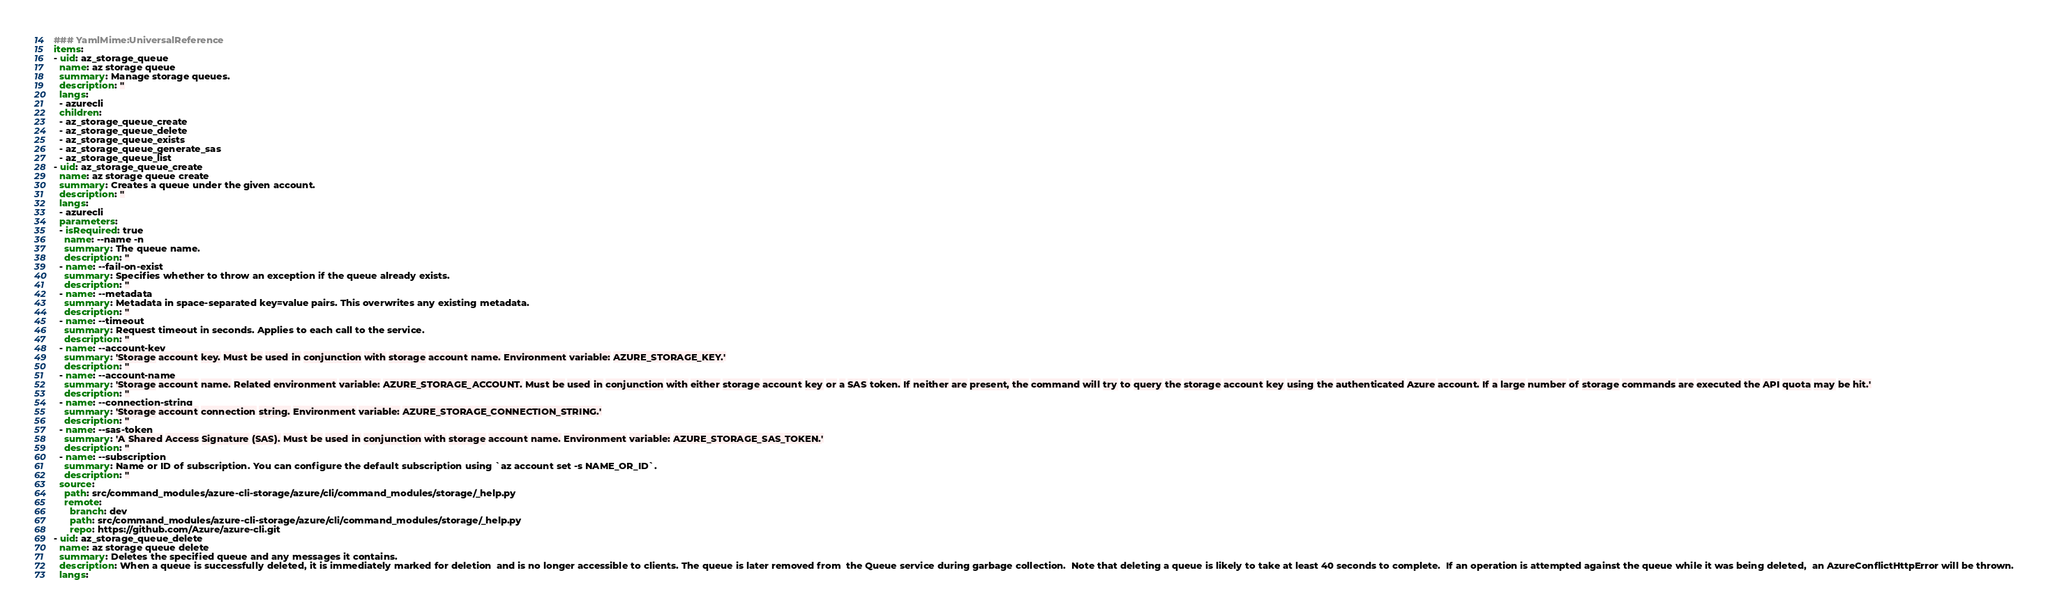<code> <loc_0><loc_0><loc_500><loc_500><_YAML_>### YamlMime:UniversalReference
items:
- uid: az_storage_queue
  name: az storage queue
  summary: Manage storage queues.
  description: ''
  langs:
  - azurecli
  children:
  - az_storage_queue_create
  - az_storage_queue_delete
  - az_storage_queue_exists
  - az_storage_queue_generate_sas
  - az_storage_queue_list
- uid: az_storage_queue_create
  name: az storage queue create
  summary: Creates a queue under the given account.
  description: ''
  langs:
  - azurecli
  parameters:
  - isRequired: true
    name: --name -n
    summary: The queue name.
    description: ''
  - name: --fail-on-exist
    summary: Specifies whether to throw an exception if the queue already exists.
    description: ''
  - name: --metadata
    summary: Metadata in space-separated key=value pairs. This overwrites any existing metadata.
    description: ''
  - name: --timeout
    summary: Request timeout in seconds. Applies to each call to the service.
    description: ''
  - name: --account-key
    summary: 'Storage account key. Must be used in conjunction with storage account name. Environment variable: AZURE_STORAGE_KEY.'
    description: ''
  - name: --account-name
    summary: 'Storage account name. Related environment variable: AZURE_STORAGE_ACCOUNT. Must be used in conjunction with either storage account key or a SAS token. If neither are present, the command will try to query the storage account key using the authenticated Azure account. If a large number of storage commands are executed the API quota may be hit.'
    description: ''
  - name: --connection-string
    summary: 'Storage account connection string. Environment variable: AZURE_STORAGE_CONNECTION_STRING.'
    description: ''
  - name: --sas-token
    summary: 'A Shared Access Signature (SAS). Must be used in conjunction with storage account name. Environment variable: AZURE_STORAGE_SAS_TOKEN.'
    description: ''
  - name: --subscription
    summary: Name or ID of subscription. You can configure the default subscription using `az account set -s NAME_OR_ID`.
    description: ''
  source:
    path: src/command_modules/azure-cli-storage/azure/cli/command_modules/storage/_help.py
    remote:
      branch: dev
      path: src/command_modules/azure-cli-storage/azure/cli/command_modules/storage/_help.py
      repo: https://github.com/Azure/azure-cli.git
- uid: az_storage_queue_delete
  name: az storage queue delete
  summary: Deletes the specified queue and any messages it contains.
  description: When a queue is successfully deleted, it is immediately marked for deletion  and is no longer accessible to clients. The queue is later removed from  the Queue service during garbage collection.  Note that deleting a queue is likely to take at least 40 seconds to complete.  If an operation is attempted against the queue while it was being deleted,  an AzureConflictHttpError will be thrown.
  langs:</code> 